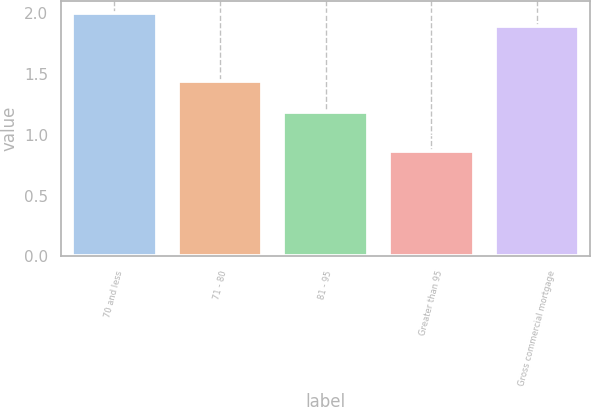Convert chart to OTSL. <chart><loc_0><loc_0><loc_500><loc_500><bar_chart><fcel>70 and less<fcel>71 - 80<fcel>81 - 95<fcel>Greater than 95<fcel>Gross commercial mortgage<nl><fcel>2<fcel>1.44<fcel>1.19<fcel>0.87<fcel>1.89<nl></chart> 